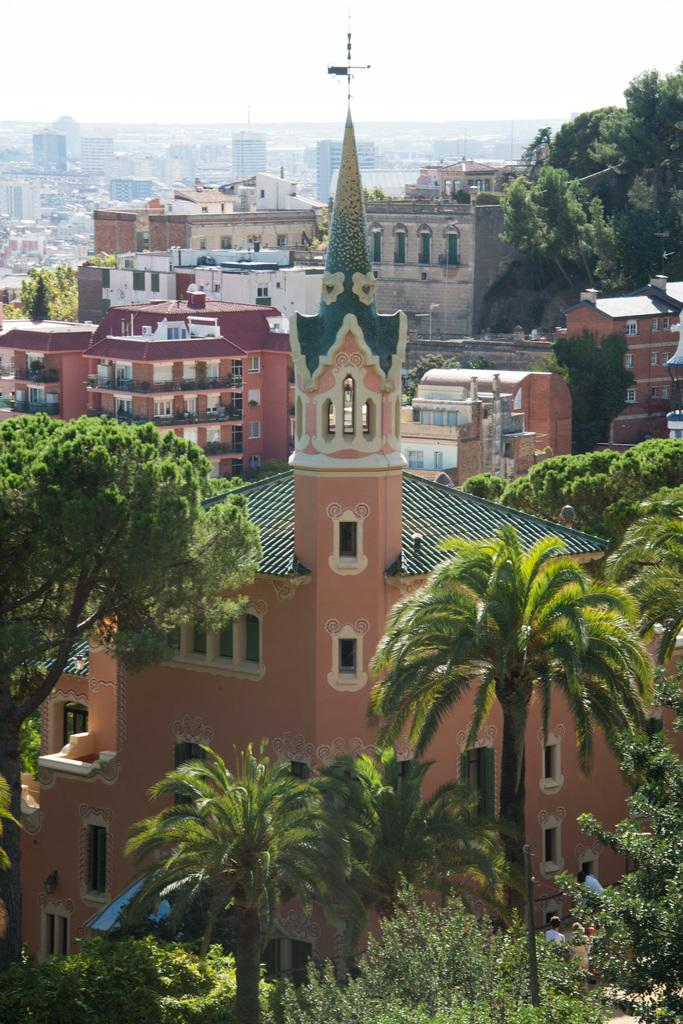What type of view is depicted in the image? The image is an aerial view. What type of vegetation can be seen in the image? There are trees visible in the image. What type of structures can be seen in the image? There are houses and buildings visible in the image. What is visible in the background of the image? The sky is visible in the image. What type of bean is being shaken by the fowl in the image? There is no bean or fowl present in the image. 